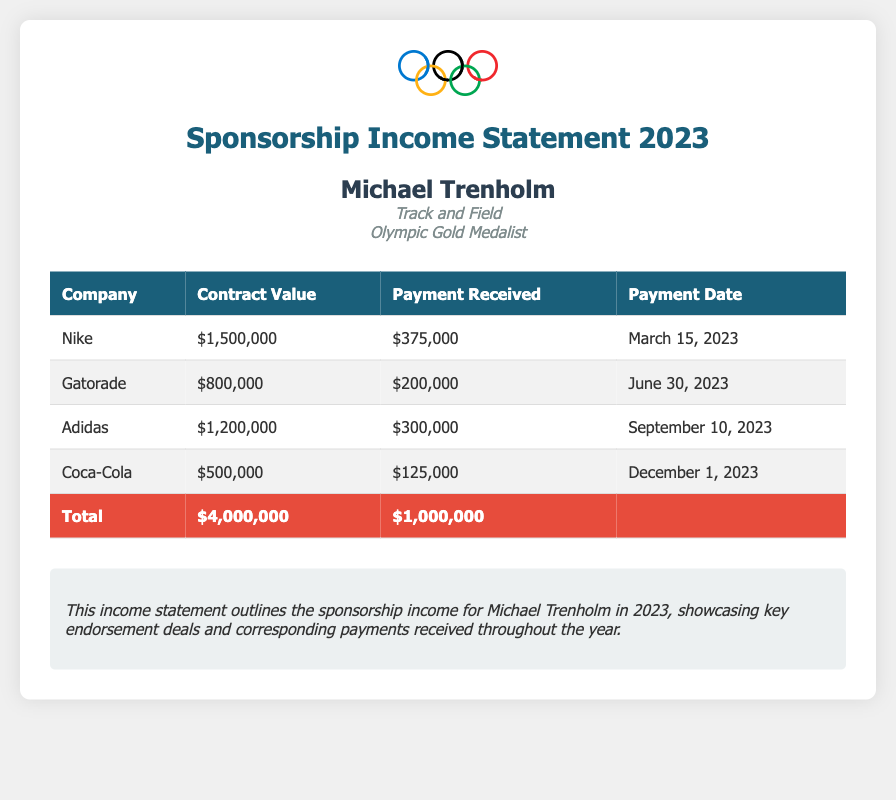What is the total contract value? The total contract value is the sum of all contract values listed in the table: $1,500,000 + $800,000 + $1,200,000 + $500,000 = $4,000,000.
Answer: $4,000,000 Who is the athlete? The name of the athlete is prominently displayed at the top of the document.
Answer: Michael Trenholm What is the sport of the athlete? The sport is specified in the athlete's information section.
Answer: Track and Field How much payment was received from Nike? The payment received from Nike is listed in the payments column of the table.
Answer: $375,000 What date was the payment from Gatorade received? The payment date for Gatorade is specifically mentioned in the corresponding row of the table.
Answer: June 30, 2023 Which company has the lowest contract value? To find the company with the lowest contract value, compare all values in the contract column.
Answer: Coca-Cola How much total payment was received? The total payment is calculated by adding all payments received, which is stated in the total row of the table.
Answer: $1,000,000 What is Michael Trenholm's achievement? The achievement of the athlete is highlighted in the athlete's information section.
Answer: Olympic Gold Medalist What was the payment received from Adidas? The payment received from Adidas can be found in the payments column of the table.
Answer: $300,000 